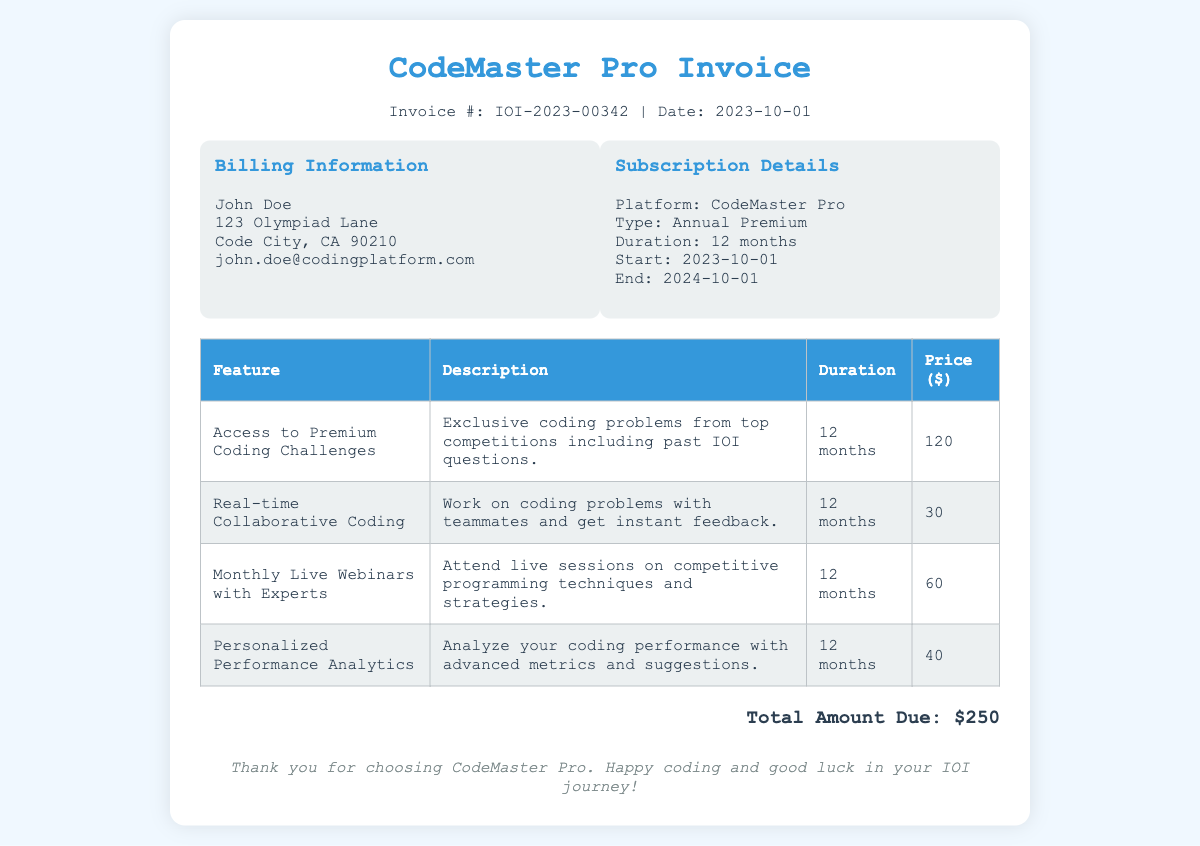What is the invoice number? The invoice number is clearly stated in the document, which is IOI-2023-00342.
Answer: IOI-2023-00342 Who is the billing person? The billing person is specified in the billing information section, which is John Doe.
Answer: John Doe What is the subscription type? The subscription type is mentioned under subscription details, which is Annual Premium.
Answer: Annual Premium When does the subscription end? The document provides the end date of the subscription, which is 2024-10-01.
Answer: 2024-10-01 How many features are listed in the document? By counting the rows in the features table, there are four features listed.
Answer: 4 What is the price of the feature "Real-time Collaborative Coding"? The document provides the price for this feature in the table, which is $30.
Answer: 30 What is the total amount due? The total amount due is indicated at the end of the document, which is $250.
Answer: $250 How long is the duration of access to Premium Coding Challenges? The duration for this feature is provided in the table as 12 months.
Answer: 12 months What type of events can one attend monthly according to the subscription? The document describes attending live sessions which are Monthly Live Webinars with Experts.
Answer: Monthly Live Webinars with Experts 